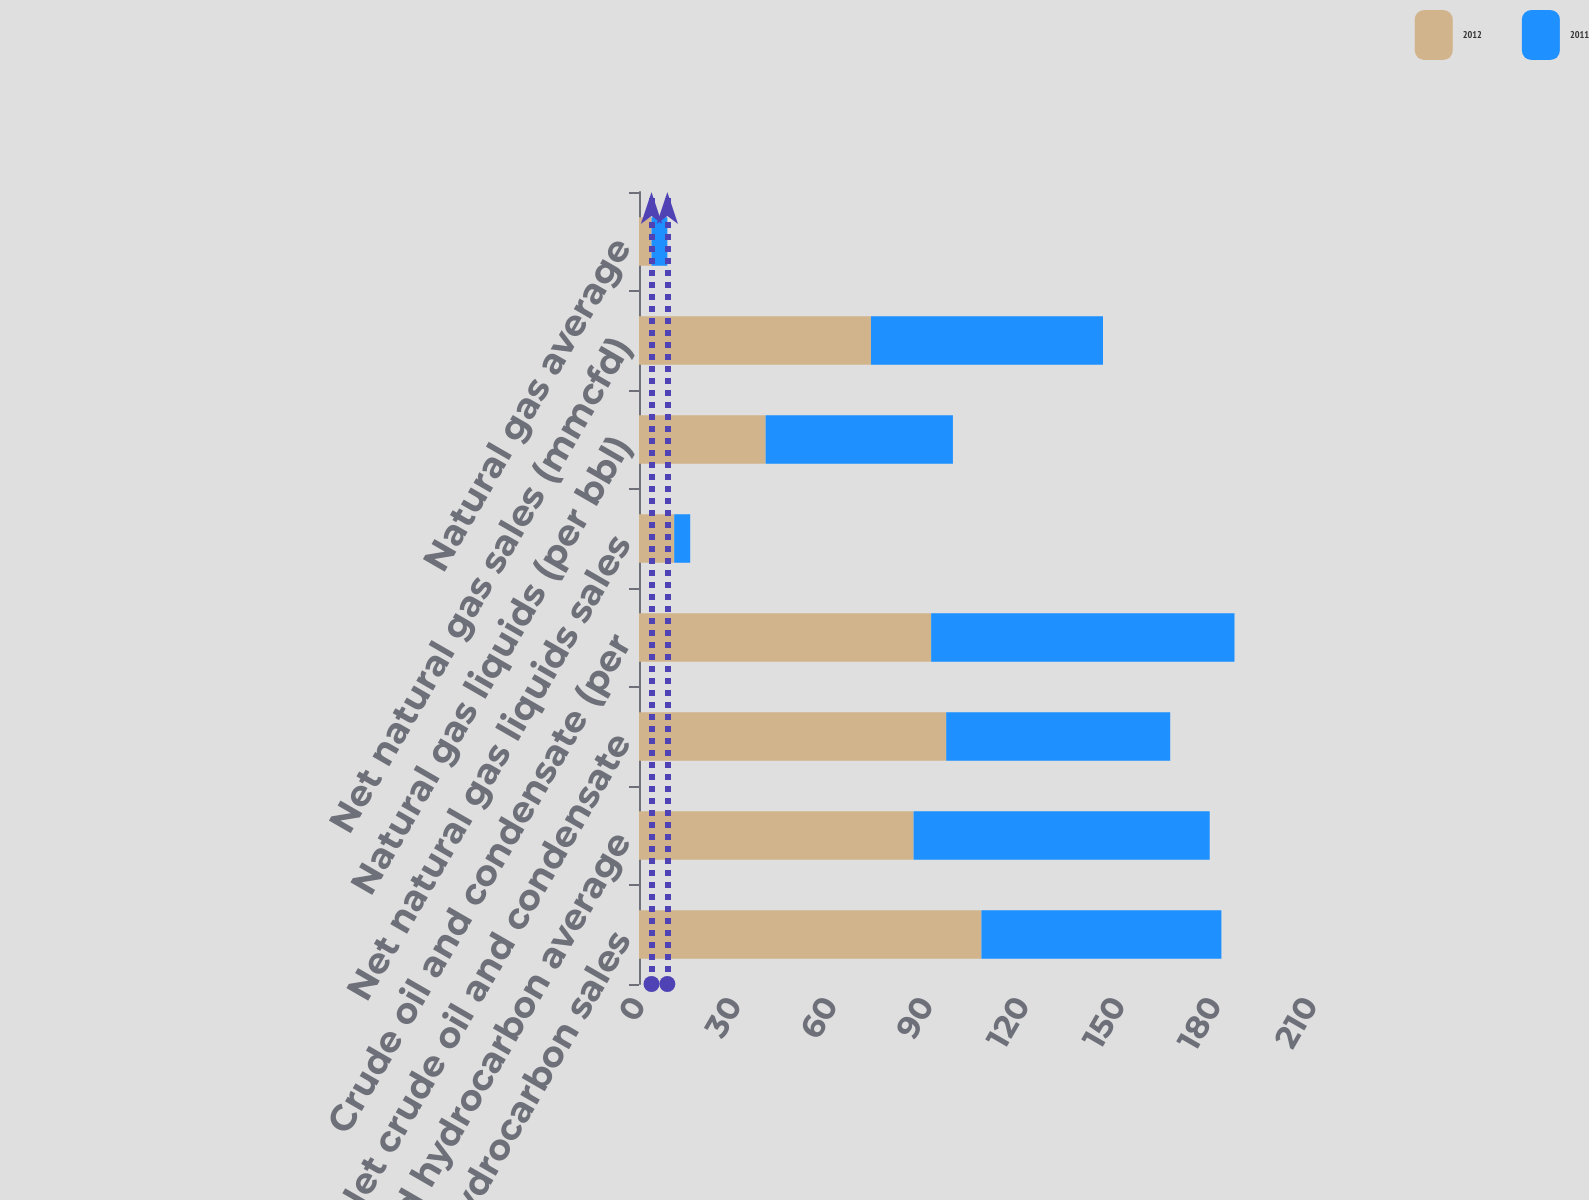Convert chart to OTSL. <chart><loc_0><loc_0><loc_500><loc_500><stacked_bar_chart><ecel><fcel>Net liquid hydrocarbon sales<fcel>Liquid hydrocarbon average<fcel>Net crude oil and condensate<fcel>Crude oil and condensate (per<fcel>Net natural gas liquids sales<fcel>Natural gas liquids (per bbl)<fcel>Net natural gas sales (mmcfd)<fcel>Natural gas average<nl><fcel>2012<fcel>107<fcel>85.8<fcel>96<fcel>91.29<fcel>11<fcel>39.57<fcel>72.5<fcel>3.91<nl><fcel>2011<fcel>75<fcel>92.55<fcel>70<fcel>94.8<fcel>5<fcel>58.53<fcel>72.5<fcel>4.95<nl></chart> 